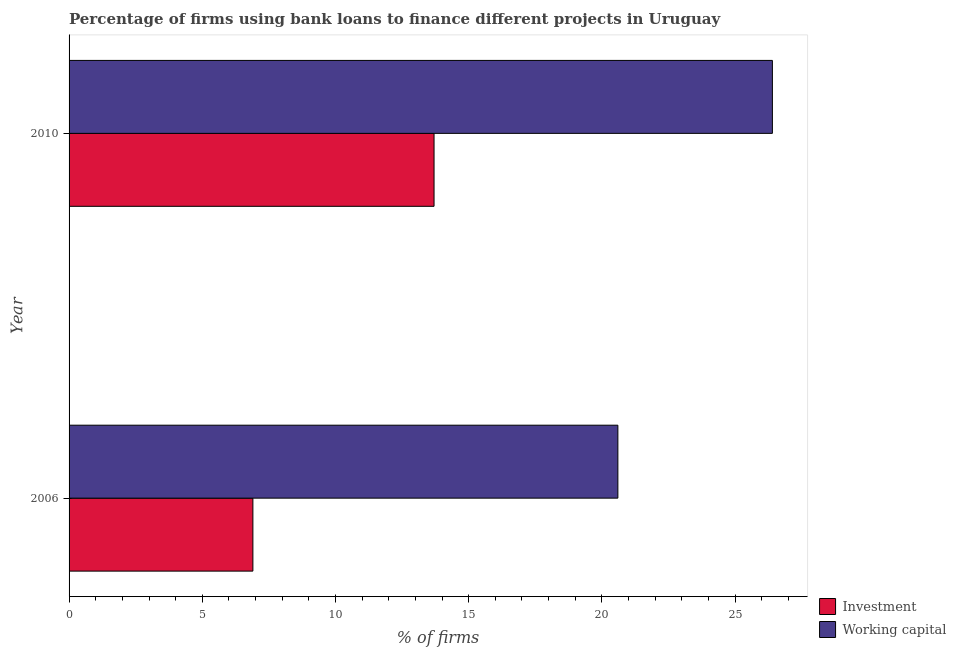How many different coloured bars are there?
Ensure brevity in your answer.  2. Are the number of bars on each tick of the Y-axis equal?
Offer a terse response. Yes. What is the label of the 1st group of bars from the top?
Ensure brevity in your answer.  2010. What is the percentage of firms using banks to finance working capital in 2006?
Give a very brief answer. 20.6. Across all years, what is the maximum percentage of firms using banks to finance investment?
Provide a succinct answer. 13.7. Across all years, what is the minimum percentage of firms using banks to finance investment?
Your response must be concise. 6.9. In which year was the percentage of firms using banks to finance working capital minimum?
Provide a short and direct response. 2006. What is the total percentage of firms using banks to finance investment in the graph?
Provide a succinct answer. 20.6. What is the difference between the percentage of firms using banks to finance working capital in 2010 and the percentage of firms using banks to finance investment in 2006?
Give a very brief answer. 19.5. What is the ratio of the percentage of firms using banks to finance working capital in 2006 to that in 2010?
Make the answer very short. 0.78. Is the difference between the percentage of firms using banks to finance working capital in 2006 and 2010 greater than the difference between the percentage of firms using banks to finance investment in 2006 and 2010?
Offer a terse response. Yes. What does the 1st bar from the top in 2010 represents?
Your response must be concise. Working capital. What does the 1st bar from the bottom in 2006 represents?
Give a very brief answer. Investment. How many bars are there?
Your response must be concise. 4. How many years are there in the graph?
Your answer should be compact. 2. What is the difference between two consecutive major ticks on the X-axis?
Provide a short and direct response. 5. Are the values on the major ticks of X-axis written in scientific E-notation?
Ensure brevity in your answer.  No. Does the graph contain any zero values?
Ensure brevity in your answer.  No. Does the graph contain grids?
Offer a very short reply. No. Where does the legend appear in the graph?
Your response must be concise. Bottom right. How are the legend labels stacked?
Your answer should be very brief. Vertical. What is the title of the graph?
Offer a terse response. Percentage of firms using bank loans to finance different projects in Uruguay. Does "Primary" appear as one of the legend labels in the graph?
Make the answer very short. No. What is the label or title of the X-axis?
Your answer should be very brief. % of firms. What is the label or title of the Y-axis?
Provide a short and direct response. Year. What is the % of firms in Working capital in 2006?
Provide a short and direct response. 20.6. What is the % of firms of Working capital in 2010?
Your answer should be very brief. 26.4. Across all years, what is the maximum % of firms in Investment?
Your answer should be compact. 13.7. Across all years, what is the maximum % of firms of Working capital?
Ensure brevity in your answer.  26.4. Across all years, what is the minimum % of firms of Working capital?
Keep it short and to the point. 20.6. What is the total % of firms of Investment in the graph?
Offer a very short reply. 20.6. What is the difference between the % of firms in Working capital in 2006 and that in 2010?
Offer a terse response. -5.8. What is the difference between the % of firms in Investment in 2006 and the % of firms in Working capital in 2010?
Make the answer very short. -19.5. What is the average % of firms in Investment per year?
Offer a very short reply. 10.3. In the year 2006, what is the difference between the % of firms in Investment and % of firms in Working capital?
Give a very brief answer. -13.7. In the year 2010, what is the difference between the % of firms in Investment and % of firms in Working capital?
Offer a terse response. -12.7. What is the ratio of the % of firms of Investment in 2006 to that in 2010?
Your answer should be very brief. 0.5. What is the ratio of the % of firms in Working capital in 2006 to that in 2010?
Offer a terse response. 0.78. What is the difference between the highest and the second highest % of firms of Investment?
Your answer should be very brief. 6.8. What is the difference between the highest and the lowest % of firms in Investment?
Ensure brevity in your answer.  6.8. 